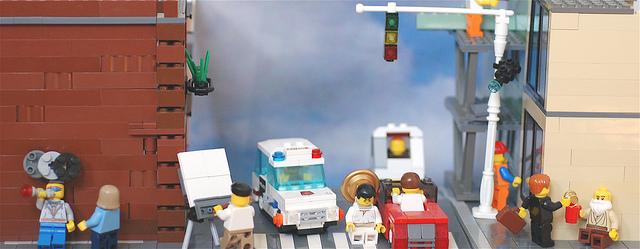What is this town built from?
Keep it brief. Legos. Why is the lego man on the far right wearing a mask?
Give a very brief answer. Robber. What is the scene in the image?
Write a very short answer. Accident. 